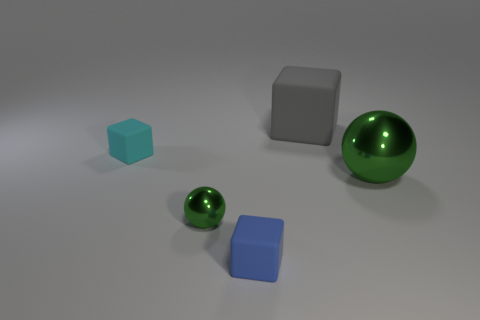Is there another small thing of the same color as the small metallic thing?
Your answer should be compact. No. Do the big sphere and the tiny metal thing have the same color?
Your response must be concise. Yes. There is a tiny ball that is the same color as the large sphere; what is it made of?
Ensure brevity in your answer.  Metal. Are the blue cube and the ball that is left of the blue cube made of the same material?
Your answer should be very brief. No. There is a large metallic object; is it the same color as the metallic ball to the left of the blue matte block?
Make the answer very short. Yes. What color is the big cube?
Offer a very short reply. Gray. How many other objects are there of the same color as the tiny sphere?
Provide a succinct answer. 1. Are there more large matte things to the right of the big metallic ball than small green metal things that are to the left of the small green object?
Give a very brief answer. No. There is a blue matte thing; are there any small rubber cubes left of it?
Your answer should be compact. Yes. There is a small thing that is behind the tiny blue rubber cube and on the right side of the tiny cyan object; what material is it made of?
Keep it short and to the point. Metal. 